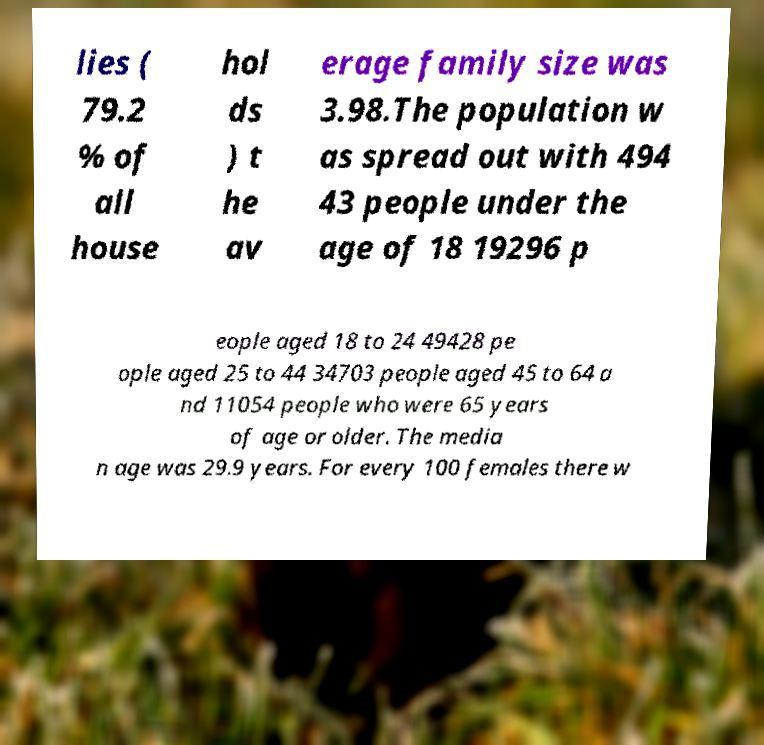What messages or text are displayed in this image? I need them in a readable, typed format. lies ( 79.2 % of all house hol ds ) t he av erage family size was 3.98.The population w as spread out with 494 43 people under the age of 18 19296 p eople aged 18 to 24 49428 pe ople aged 25 to 44 34703 people aged 45 to 64 a nd 11054 people who were 65 years of age or older. The media n age was 29.9 years. For every 100 females there w 